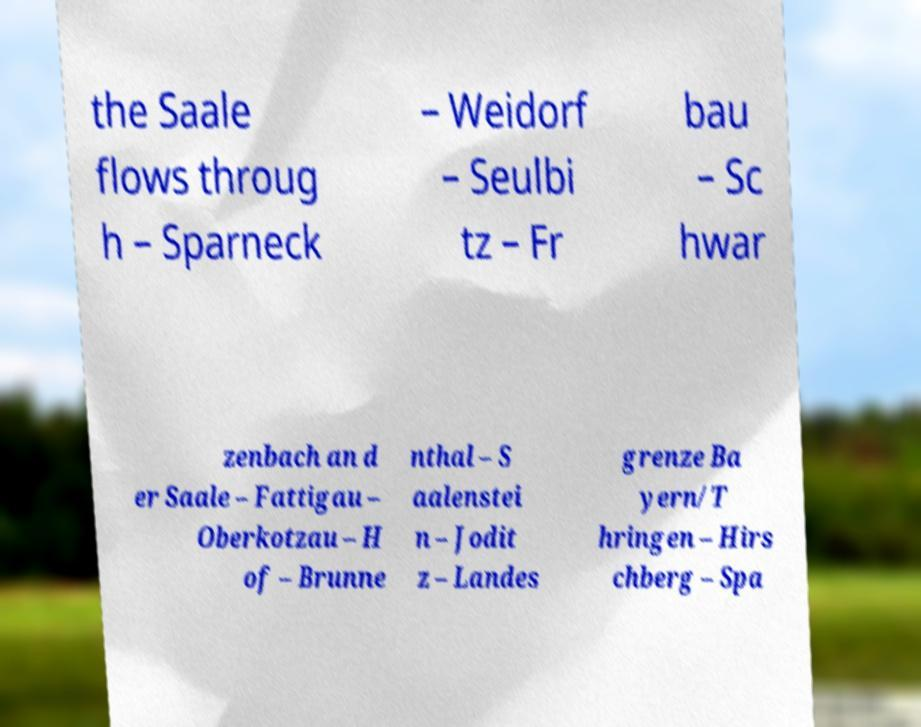Can you read and provide the text displayed in the image?This photo seems to have some interesting text. Can you extract and type it out for me? the Saale flows throug h – Sparneck – Weidorf – Seulbi tz – Fr bau – Sc hwar zenbach an d er Saale – Fattigau – Oberkotzau – H of – Brunne nthal – S aalenstei n – Jodit z – Landes grenze Ba yern/T hringen – Hirs chberg – Spa 